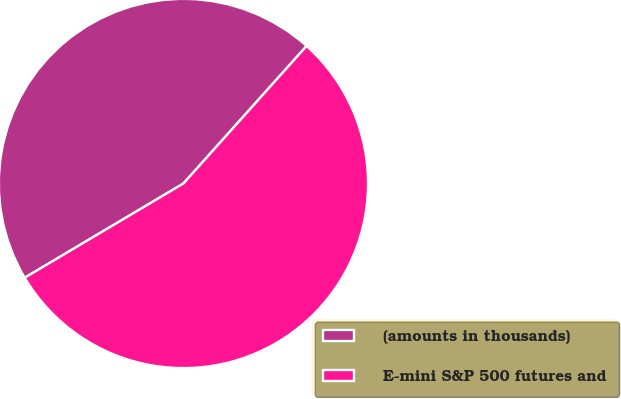<chart> <loc_0><loc_0><loc_500><loc_500><pie_chart><fcel>(amounts in thousands)<fcel>E-mini S&P 500 futures and<nl><fcel>45.15%<fcel>54.85%<nl></chart> 